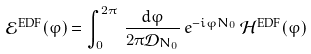<formula> <loc_0><loc_0><loc_500><loc_500>\mathcal { E } ^ { \text {EDF} } ( \varphi ) = \int _ { 0 } ^ { 2 \pi } \, \frac { d \varphi } { 2 \pi \mathcal { D } _ { N _ { 0 } } } \, e ^ { - i \varphi N _ { 0 } } \, \mathcal { H } ^ { \text {EDF} } ( \varphi )</formula> 